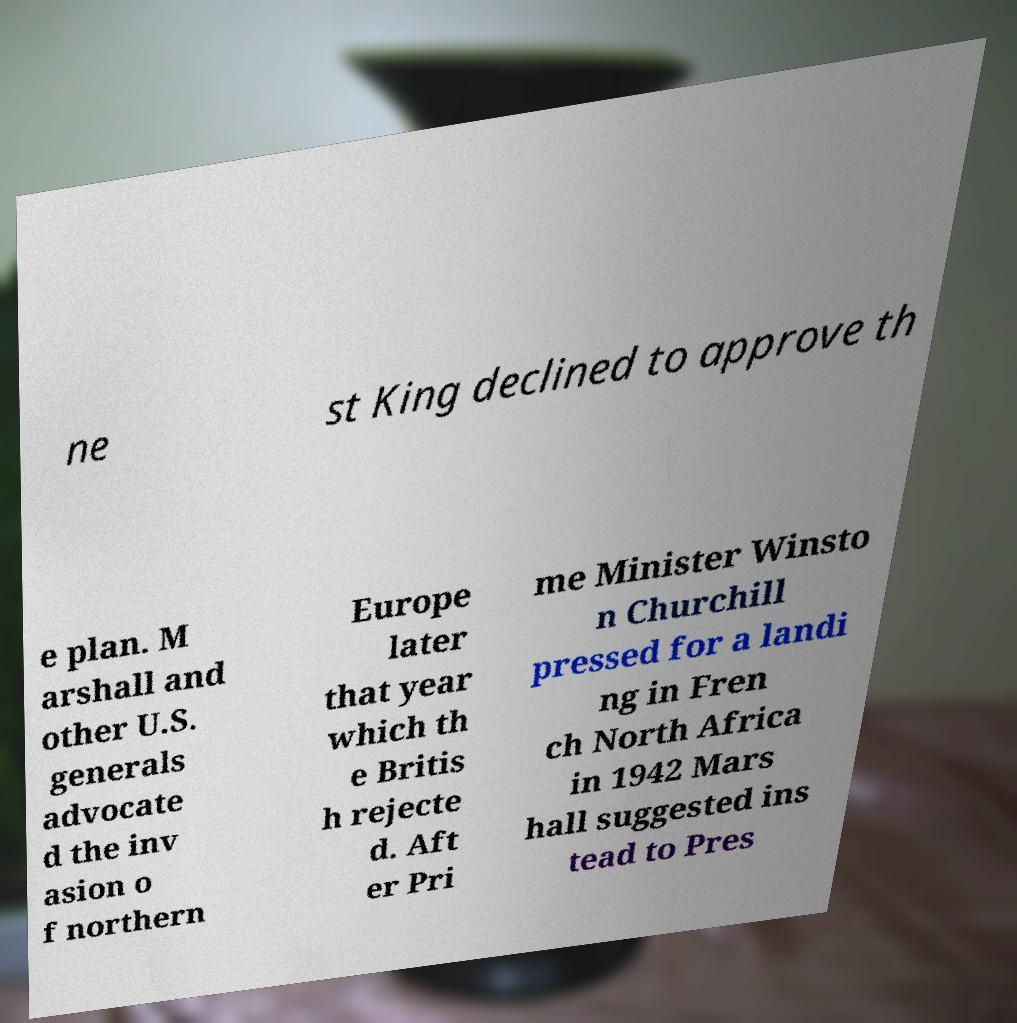I need the written content from this picture converted into text. Can you do that? ne st King declined to approve th e plan. M arshall and other U.S. generals advocate d the inv asion o f northern Europe later that year which th e Britis h rejecte d. Aft er Pri me Minister Winsto n Churchill pressed for a landi ng in Fren ch North Africa in 1942 Mars hall suggested ins tead to Pres 